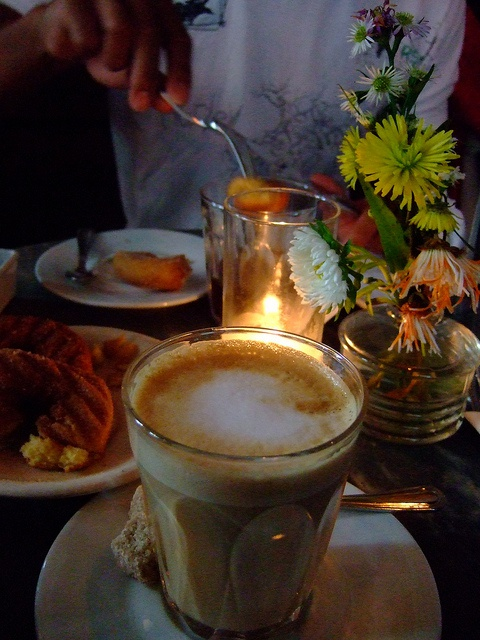Describe the objects in this image and their specific colors. I can see cup in gray, black, olive, and maroon tones, people in gray, black, and maroon tones, vase in gray, black, maroon, olive, and brown tones, dining table in black, maroon, and gray tones, and sandwich in gray, black, maroon, and olive tones in this image. 